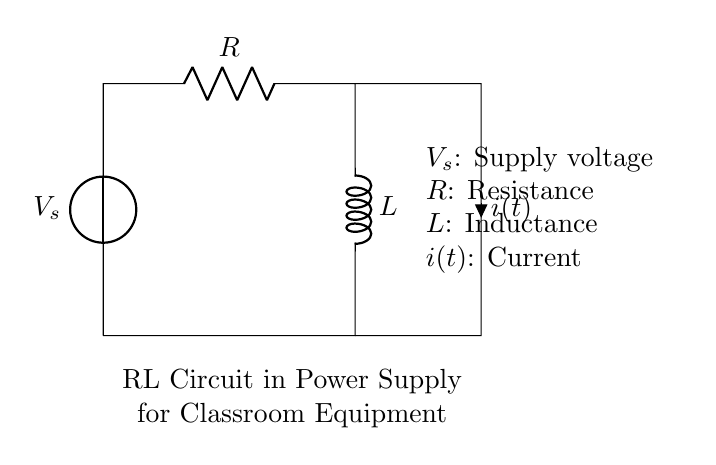What components are present in the circuit? The circuit contains a voltage source, a resistor, and an inductor. These components are clearly labeled in the circuit diagram.
Answer: Voltage source, resistor, inductor What is the function of the inductor in this circuit? The inductor stores energy in a magnetic field when current flows through it. Its role is to oppose changes in current, which helps stabilize the power supply for the equipment.
Answer: Store energy What is the current notation used in the circuit? The current in the circuit is denoted as i(t), indicating that it is a function of time. This notation suggests that current may vary over time, which is typical in RL circuits.
Answer: i(t) How does increasing resistance affect the current? Increasing the resistance in the circuit will decrease the current, according to Ohm's law, since current is inversely proportional to resistance when voltage is constant.
Answer: Decreases current What happens to the voltage across the inductor when the current changes? When the current changes, the inductor will generate a voltage that opposes this change, according to Lenz's law. This means that the voltage across the inductor will work against the applied voltage in the circuit.
Answer: Opposes change What type of circuit configuration is used here? The configuration is a series RL circuit where the resistor and inductor are connected in series with the voltage source. This type of configuration affects the behavior of current and voltage in the circuit.
Answer: Series RL circuit 